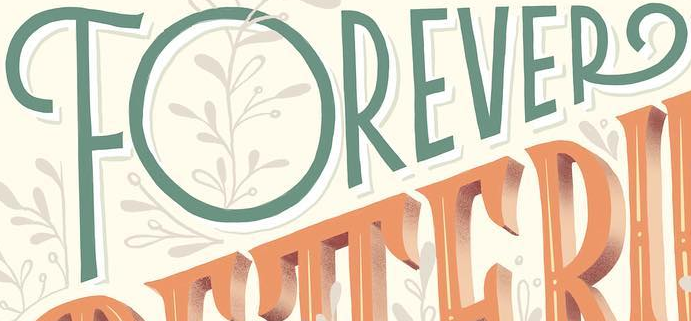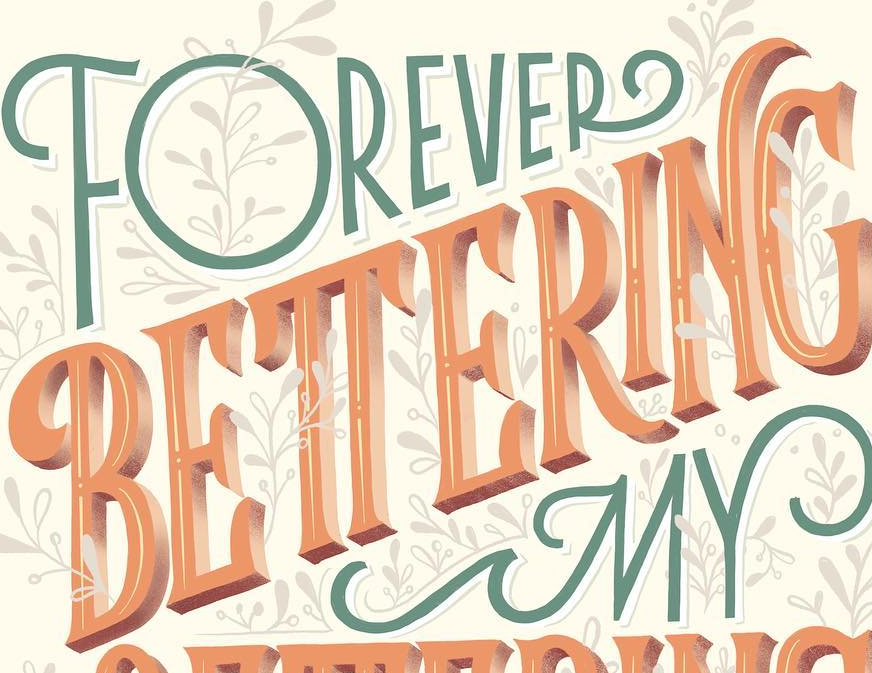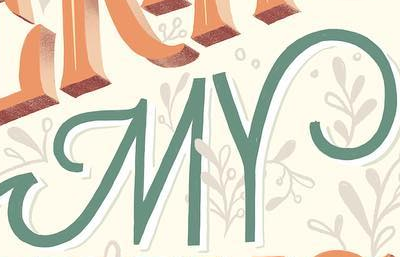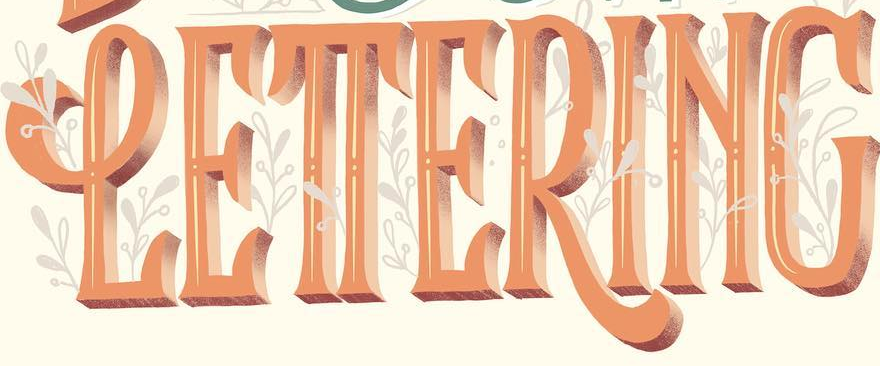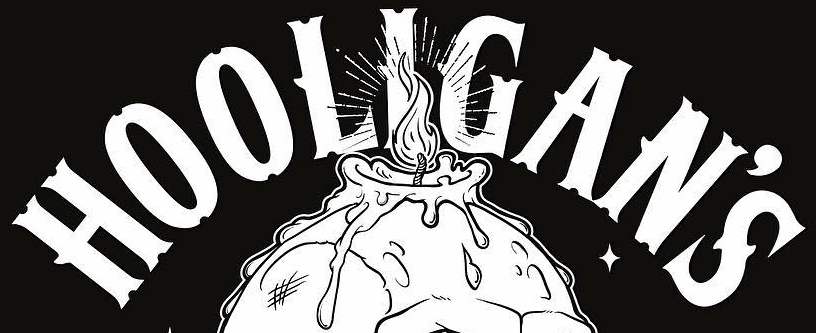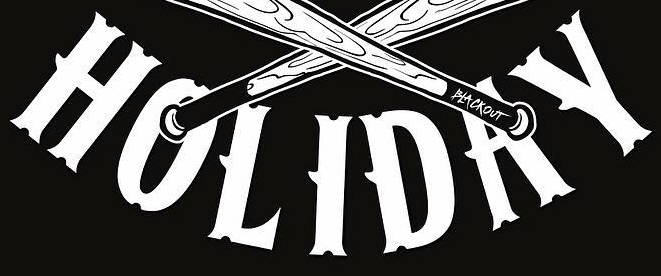Read the text from these images in sequence, separated by a semicolon. FOREVER; BETTERING; MY; LETTERING; HOOLIGAN'S; HOLIDAY 